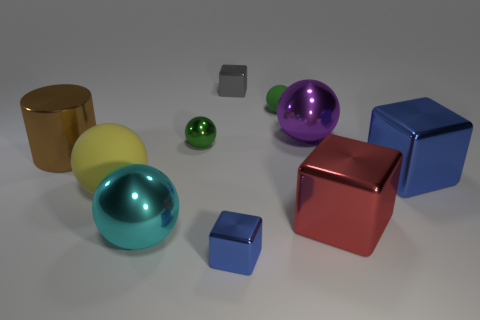How many other things are there of the same material as the large red block?
Ensure brevity in your answer.  7. Is the size of the green rubber thing the same as the gray cube?
Offer a terse response. Yes. How many objects are large shiny things that are in front of the big blue block or cylinders?
Provide a succinct answer. 3. What is the material of the small green thing that is on the right side of the tiny thing that is in front of the red cube?
Your answer should be very brief. Rubber. Are there any other objects of the same shape as the green metallic thing?
Give a very brief answer. Yes. There is a red cube; is it the same size as the green ball that is on the right side of the tiny gray metal thing?
Make the answer very short. No. What number of things are either objects that are in front of the gray metallic thing or objects that are right of the big red metallic block?
Provide a short and direct response. 9. Are there more large objects that are in front of the large brown metal cylinder than tiny balls?
Make the answer very short. Yes. What number of cyan objects are the same size as the green shiny thing?
Ensure brevity in your answer.  0. There is a green object that is to the left of the tiny gray metal block; is its size the same as the blue metallic block behind the large red cube?
Provide a succinct answer. No. 